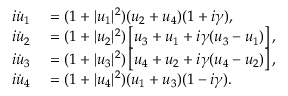<formula> <loc_0><loc_0><loc_500><loc_500>\begin{array} { r l } { i \dot { u } _ { 1 } } & = ( 1 + | u _ { 1 } | ^ { 2 } ) ( u _ { 2 } + u _ { 4 } ) ( 1 + i \gamma ) , } \\ { i \dot { u } _ { 2 } } & = ( 1 + | u _ { 2 } | ^ { 2 } ) \left [ u _ { 3 } + u _ { 1 } + i \gamma ( u _ { 3 } - u _ { 1 } ) \right ] , } \\ { i \dot { u } _ { 3 } } & = ( 1 + | u _ { 3 } | ^ { 2 } ) \left [ u _ { 4 } + u _ { 2 } + i \gamma ( u _ { 4 } - u _ { 2 } ) \right ] , } \\ { i \dot { u } _ { 4 } } & = ( 1 + | u _ { 4 } | ^ { 2 } ) ( u _ { 1 } + u _ { 3 } ) ( 1 - i \gamma ) . } \end{array}</formula> 